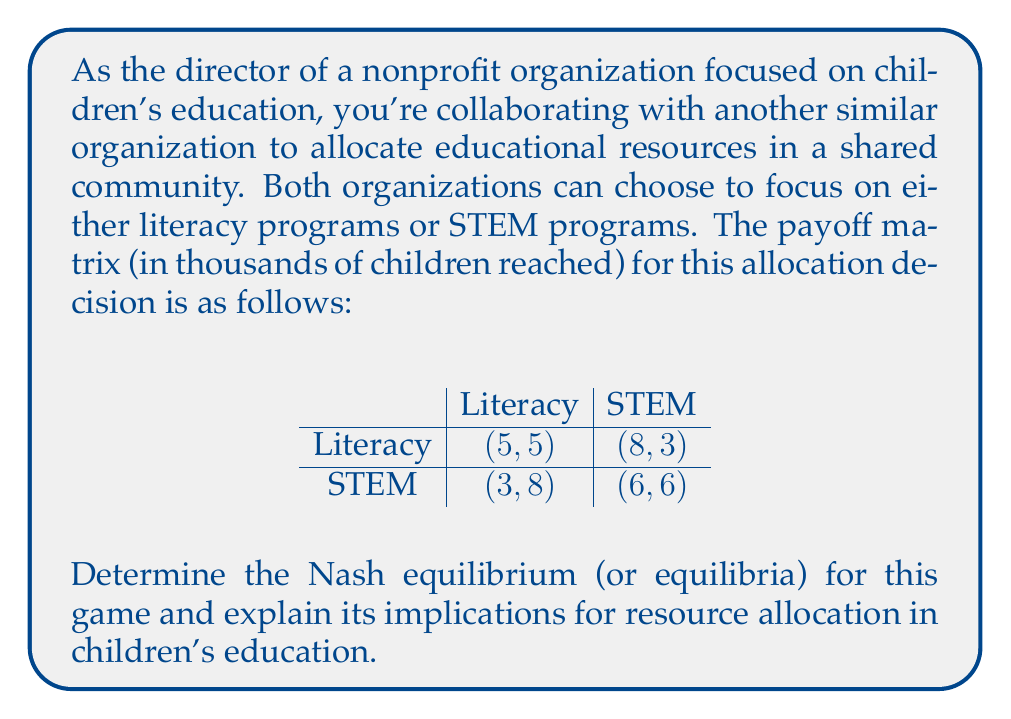Teach me how to tackle this problem. To find the Nash equilibrium, we need to analyze each organization's best response to the other's strategy:

1. If Organization 1 chooses Literacy:
   - Organization 2's best response is Literacy (5 > 3)
2. If Organization 1 chooses STEM:
   - Organization 2's best response is STEM (6 > 3)
3. If Organization 2 chooses Literacy:
   - Organization 1's best response is STEM (8 > 5)
4. If Organization 2 chooses STEM:
   - Organization 1's best response is STEM (6 > 3)

From this analysis, we can see that (STEM, STEM) is a Nash equilibrium, as neither organization has an incentive to unilaterally deviate from this strategy.

To check if there are any mixed strategy equilibria, we need to calculate the expected payoffs for each strategy:

Let $p$ be the probability that Organization 1 chooses Literacy, and $q$ be the probability that Organization 2 chooses Literacy.

For Organization 1:
$$E(\text{Literacy}) = 5q + 8(1-q) = 8 - 3q$$
$$E(\text{STEM}) = 3q + 6(1-q) = 6 - 3q$$

For these to be equal:
$$8 - 3q = 6 - 3q$$
$$8 = 6$$

This equation has no solution, indicating there is no mixed strategy equilibrium.

The same analysis applies to Organization 2 due to the symmetry of the payoff matrix.

Therefore, the only Nash equilibrium is the pure strategy (STEM, STEM).

Implications:
1. Both organizations focusing on STEM programs leads to a stable outcome, but it may not be the most efficient allocation of resources.
2. The equilibrium reaches 6,000 children each, totaling 12,000, which is less than the 16,000 that could be reached if one focused on Literacy and the other on STEM.
3. This situation demonstrates the potential for coordination failure in educational resource allocation, highlighting the need for communication and cooperation between organizations to achieve optimal outcomes for children's education.
Answer: The Nash equilibrium is (STEM, STEM), where both organizations focus on STEM programs, resulting in each organization reaching 6,000 children. 